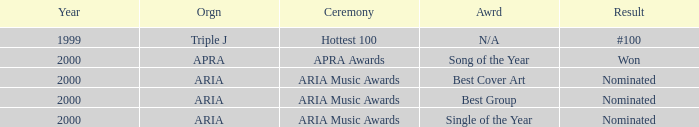What were the results before the year 2000? #100. 